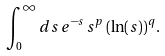Convert formula to latex. <formula><loc_0><loc_0><loc_500><loc_500>\int _ { 0 } ^ { \infty } d s \, e ^ { - s } \, s ^ { p } \, ( \ln ( s ) ) ^ { q } .</formula> 